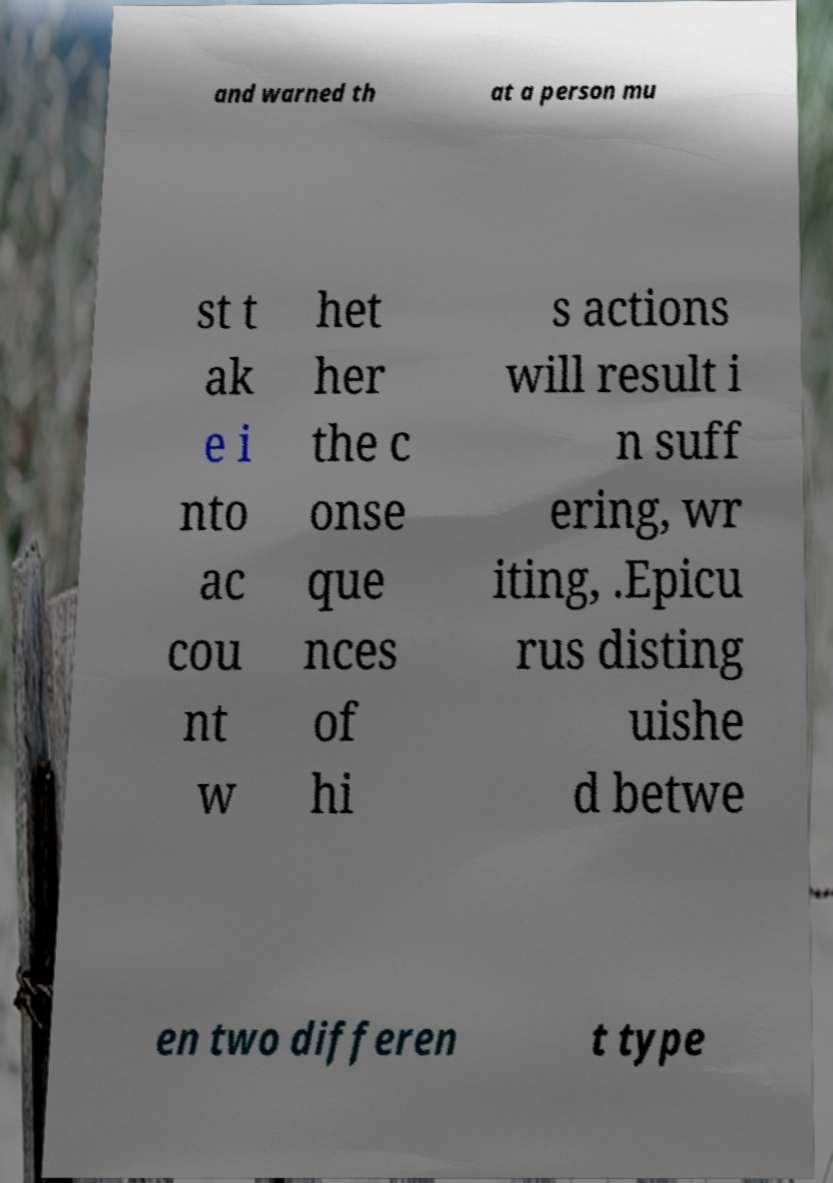There's text embedded in this image that I need extracted. Can you transcribe it verbatim? and warned th at a person mu st t ak e i nto ac cou nt w het her the c onse que nces of hi s actions will result i n suff ering, wr iting, .Epicu rus disting uishe d betwe en two differen t type 